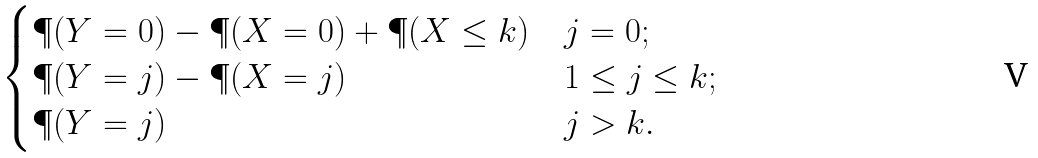<formula> <loc_0><loc_0><loc_500><loc_500>\begin{cases} \P ( Y = 0 ) - \P ( X = 0 ) + \P ( X \leq k ) & j = 0 ; \\ \P ( Y = j ) - \P ( X = j ) & 1 \leq j \leq k ; \\ \P ( Y = j ) & j > k . \end{cases}</formula> 